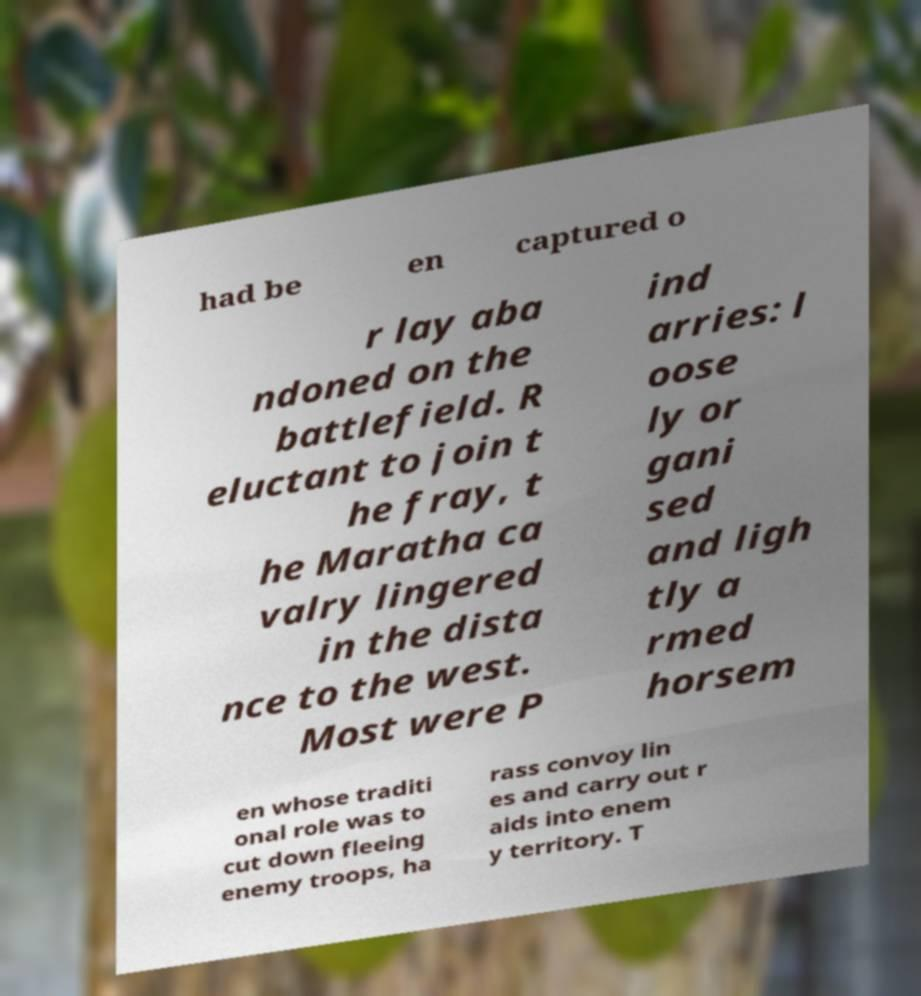For documentation purposes, I need the text within this image transcribed. Could you provide that? had be en captured o r lay aba ndoned on the battlefield. R eluctant to join t he fray, t he Maratha ca valry lingered in the dista nce to the west. Most were P ind arries: l oose ly or gani sed and ligh tly a rmed horsem en whose traditi onal role was to cut down fleeing enemy troops, ha rass convoy lin es and carry out r aids into enem y territory. T 